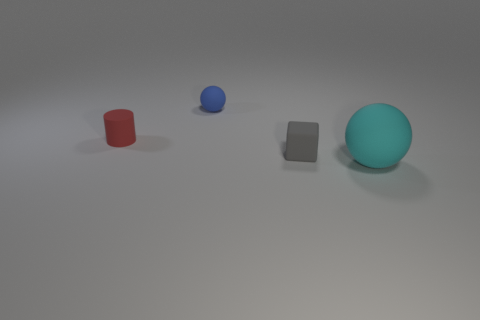How many small objects are either red metal cylinders or gray matte blocks?
Offer a very short reply. 1. There is a rubber object left of the small blue matte object; are there any blue objects that are on the left side of it?
Your response must be concise. No. Are any large yellow metal balls visible?
Provide a succinct answer. No. What is the color of the small thing behind the small matte thing left of the small matte sphere?
Your response must be concise. Blue. There is a small blue object that is the same shape as the large cyan rubber object; what is it made of?
Provide a succinct answer. Rubber. What number of gray shiny cylinders are the same size as the block?
Ensure brevity in your answer.  0. There is a red thing that is the same material as the tiny blue object; what size is it?
Provide a succinct answer. Small. How many red objects have the same shape as the cyan thing?
Your answer should be very brief. 0. What number of tiny cyan shiny balls are there?
Offer a terse response. 0. Do the small rubber object that is behind the matte cylinder and the big thing have the same shape?
Make the answer very short. Yes. 